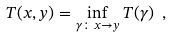<formula> <loc_0><loc_0><loc_500><loc_500>T ( x , y ) = \inf _ { \gamma \colon x \to y } T ( \gamma ) \ ,</formula> 